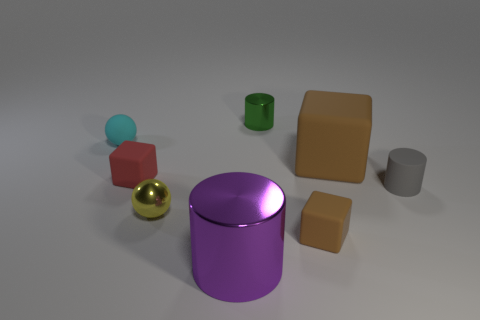How many objects in the image have corners? There are four objects in the image that have corners: two cubes and two cuboids. 